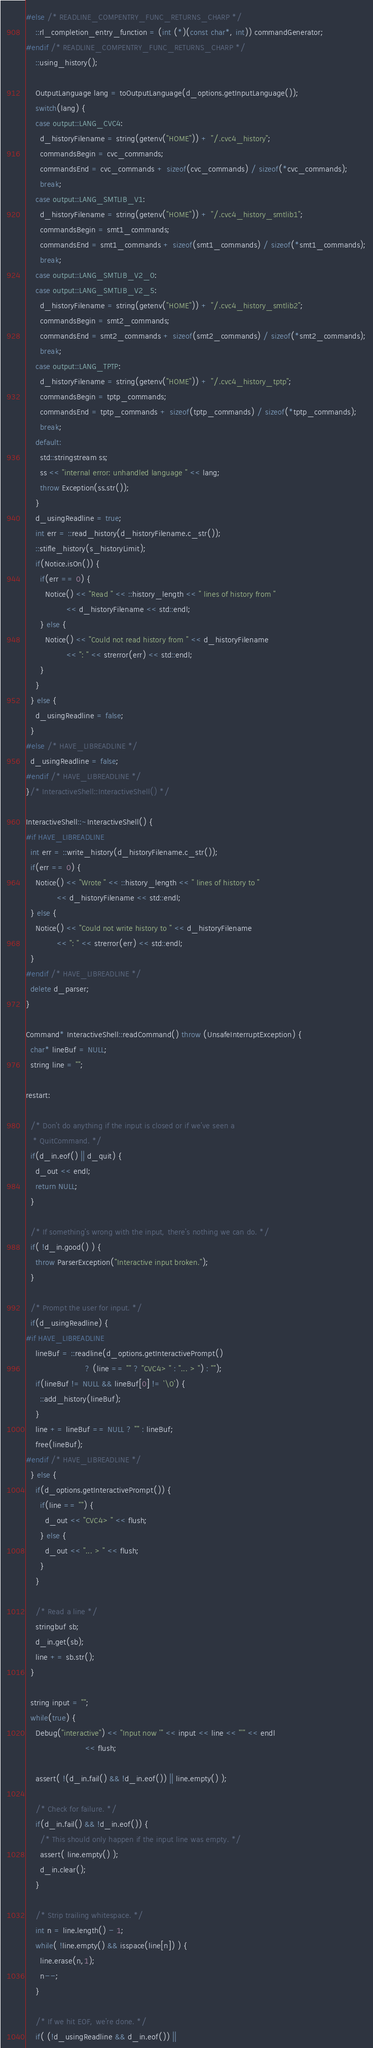Convert code to text. <code><loc_0><loc_0><loc_500><loc_500><_C++_>#else /* READLINE_COMPENTRY_FUNC_RETURNS_CHARP */
    ::rl_completion_entry_function = (int (*)(const char*, int)) commandGenerator;
#endif /* READLINE_COMPENTRY_FUNC_RETURNS_CHARP */
    ::using_history();

    OutputLanguage lang = toOutputLanguage(d_options.getInputLanguage());
    switch(lang) {
    case output::LANG_CVC4:
      d_historyFilename = string(getenv("HOME")) + "/.cvc4_history";
      commandsBegin = cvc_commands;
      commandsEnd = cvc_commands + sizeof(cvc_commands) / sizeof(*cvc_commands);
      break;
    case output::LANG_SMTLIB_V1:
      d_historyFilename = string(getenv("HOME")) + "/.cvc4_history_smtlib1";
      commandsBegin = smt1_commands;
      commandsEnd = smt1_commands + sizeof(smt1_commands) / sizeof(*smt1_commands);
      break;
    case output::LANG_SMTLIB_V2_0:
    case output::LANG_SMTLIB_V2_5:
      d_historyFilename = string(getenv("HOME")) + "/.cvc4_history_smtlib2";
      commandsBegin = smt2_commands;
      commandsEnd = smt2_commands + sizeof(smt2_commands) / sizeof(*smt2_commands);
      break;
    case output::LANG_TPTP:
      d_historyFilename = string(getenv("HOME")) + "/.cvc4_history_tptp";
      commandsBegin = tptp_commands;
      commandsEnd = tptp_commands + sizeof(tptp_commands) / sizeof(*tptp_commands);
      break;
    default:
      std::stringstream ss;
      ss << "internal error: unhandled language " << lang;
      throw Exception(ss.str());
    }
    d_usingReadline = true;
    int err = ::read_history(d_historyFilename.c_str());
    ::stifle_history(s_historyLimit);
    if(Notice.isOn()) {
      if(err == 0) {
        Notice() << "Read " << ::history_length << " lines of history from "
                 << d_historyFilename << std::endl;
      } else {
        Notice() << "Could not read history from " << d_historyFilename
                 << ": " << strerror(err) << std::endl;
      }
    }
  } else {
    d_usingReadline = false;
  }
#else /* HAVE_LIBREADLINE */
  d_usingReadline = false;
#endif /* HAVE_LIBREADLINE */
}/* InteractiveShell::InteractiveShell() */

InteractiveShell::~InteractiveShell() {
#if HAVE_LIBREADLINE
  int err = ::write_history(d_historyFilename.c_str());
  if(err == 0) {
    Notice() << "Wrote " << ::history_length << " lines of history to "
             << d_historyFilename << std::endl;
  } else {
    Notice() << "Could not write history to " << d_historyFilename
             << ": " << strerror(err) << std::endl;
  }
#endif /* HAVE_LIBREADLINE */
  delete d_parser;
}

Command* InteractiveShell::readCommand() throw (UnsafeInterruptException) {
  char* lineBuf = NULL;
  string line = "";

restart:

  /* Don't do anything if the input is closed or if we've seen a
   * QuitCommand. */
  if(d_in.eof() || d_quit) {
    d_out << endl;
    return NULL;
  }

  /* If something's wrong with the input, there's nothing we can do. */
  if( !d_in.good() ) {
    throw ParserException("Interactive input broken.");
  }

  /* Prompt the user for input. */
  if(d_usingReadline) {
#if HAVE_LIBREADLINE
    lineBuf = ::readline(d_options.getInteractivePrompt()
                         ? (line == "" ? "CVC4> " : "... > ") : "");
    if(lineBuf != NULL && lineBuf[0] != '\0') {
      ::add_history(lineBuf);
    }
    line += lineBuf == NULL ? "" : lineBuf;
    free(lineBuf);
#endif /* HAVE_LIBREADLINE */
  } else {
    if(d_options.getInteractivePrompt()) {
      if(line == "") {
        d_out << "CVC4> " << flush;
      } else {
        d_out << "... > " << flush;
      }
    }

    /* Read a line */
    stringbuf sb;
    d_in.get(sb);
    line += sb.str();
  }

  string input = "";
  while(true) {
    Debug("interactive") << "Input now '" << input << line << "'" << endl
                         << flush;

    assert( !(d_in.fail() && !d_in.eof()) || line.empty() );

    /* Check for failure. */
    if(d_in.fail() && !d_in.eof()) {
      /* This should only happen if the input line was empty. */
      assert( line.empty() );
      d_in.clear();
    }

    /* Strip trailing whitespace. */
    int n = line.length() - 1;
    while( !line.empty() && isspace(line[n]) ) {
      line.erase(n,1);
      n--;
    }

    /* If we hit EOF, we're done. */
    if( (!d_usingReadline && d_in.eof()) ||</code> 